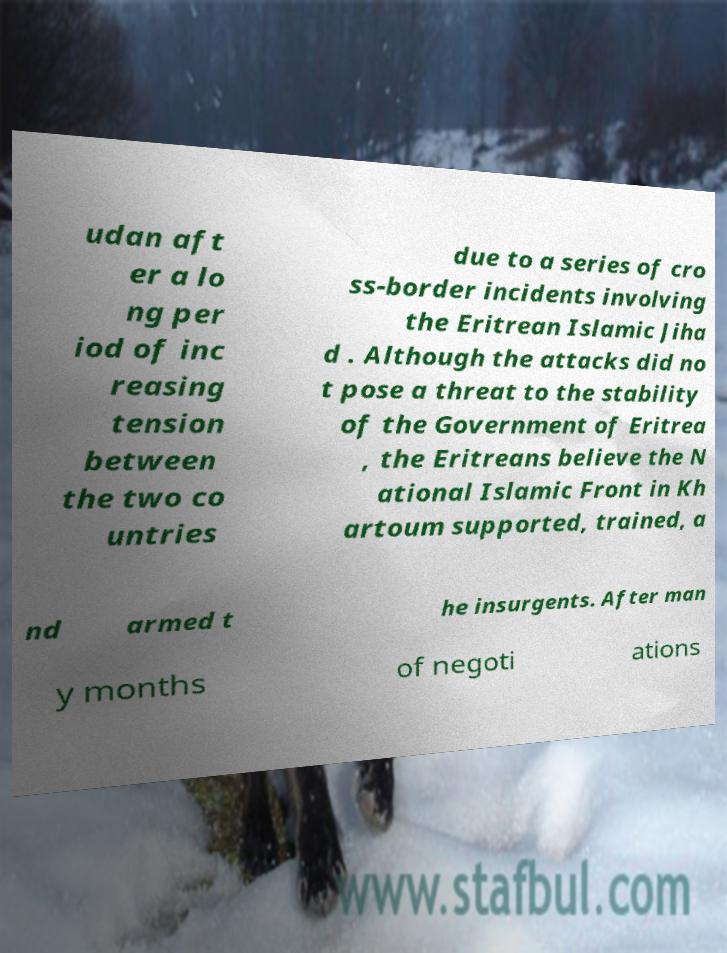What messages or text are displayed in this image? I need them in a readable, typed format. udan aft er a lo ng per iod of inc reasing tension between the two co untries due to a series of cro ss-border incidents involving the Eritrean Islamic Jiha d . Although the attacks did no t pose a threat to the stability of the Government of Eritrea , the Eritreans believe the N ational Islamic Front in Kh artoum supported, trained, a nd armed t he insurgents. After man y months of negoti ations 